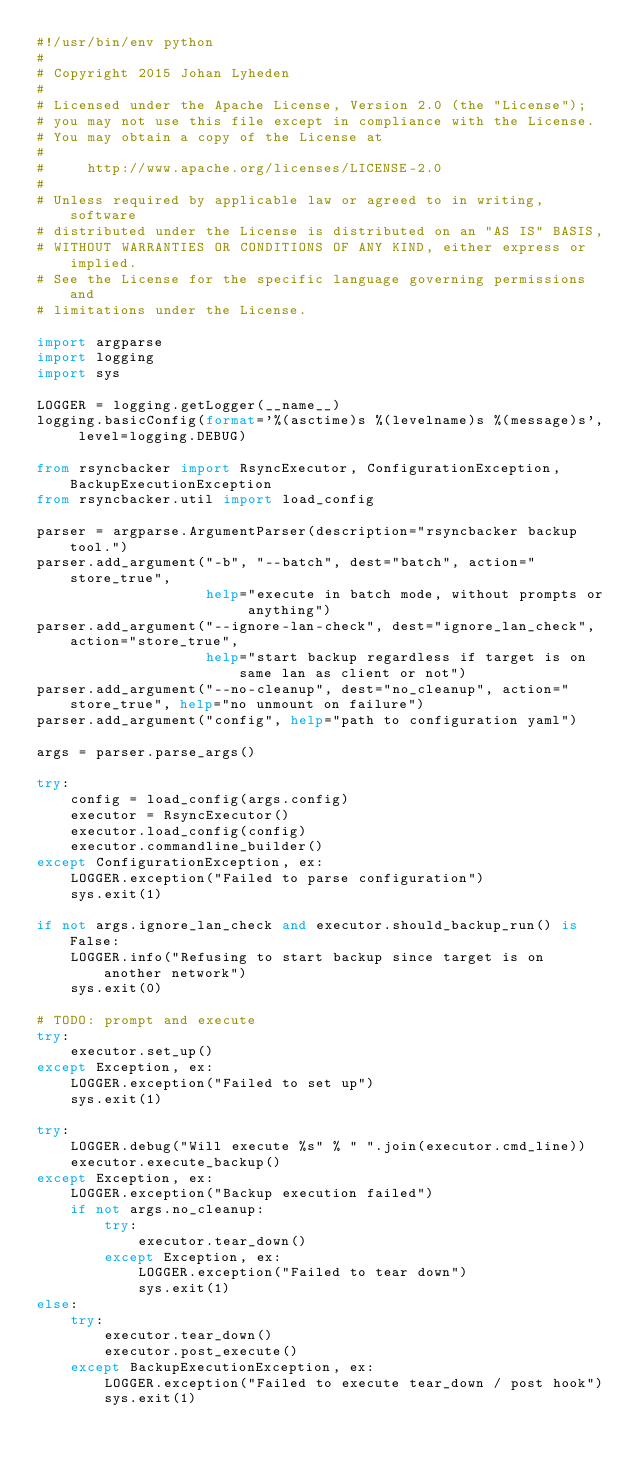<code> <loc_0><loc_0><loc_500><loc_500><_Python_>#!/usr/bin/env python
#
# Copyright 2015 Johan Lyheden
#
# Licensed under the Apache License, Version 2.0 (the "License");
# you may not use this file except in compliance with the License.
# You may obtain a copy of the License at
#
#     http://www.apache.org/licenses/LICENSE-2.0
#
# Unless required by applicable law or agreed to in writing, software
# distributed under the License is distributed on an "AS IS" BASIS,
# WITHOUT WARRANTIES OR CONDITIONS OF ANY KIND, either express or implied.
# See the License for the specific language governing permissions and
# limitations under the License.

import argparse
import logging
import sys

LOGGER = logging.getLogger(__name__)
logging.basicConfig(format='%(asctime)s %(levelname)s %(message)s', level=logging.DEBUG)

from rsyncbacker import RsyncExecutor, ConfigurationException, BackupExecutionException
from rsyncbacker.util import load_config

parser = argparse.ArgumentParser(description="rsyncbacker backup tool.")
parser.add_argument("-b", "--batch", dest="batch", action="store_true",
                    help="execute in batch mode, without prompts or anything")
parser.add_argument("--ignore-lan-check", dest="ignore_lan_check", action="store_true",
                    help="start backup regardless if target is on same lan as client or not")
parser.add_argument("--no-cleanup", dest="no_cleanup", action="store_true", help="no unmount on failure")
parser.add_argument("config", help="path to configuration yaml")

args = parser.parse_args()

try:
    config = load_config(args.config)
    executor = RsyncExecutor()
    executor.load_config(config)
    executor.commandline_builder()
except ConfigurationException, ex:
    LOGGER.exception("Failed to parse configuration")
    sys.exit(1)

if not args.ignore_lan_check and executor.should_backup_run() is False:
    LOGGER.info("Refusing to start backup since target is on another network")
    sys.exit(0)

# TODO: prompt and execute
try:
    executor.set_up()
except Exception, ex:
    LOGGER.exception("Failed to set up")
    sys.exit(1)

try:
    LOGGER.debug("Will execute %s" % " ".join(executor.cmd_line))
    executor.execute_backup()
except Exception, ex:
    LOGGER.exception("Backup execution failed")
    if not args.no_cleanup:
        try:
            executor.tear_down()
        except Exception, ex:
            LOGGER.exception("Failed to tear down")
            sys.exit(1)
else:
    try:
        executor.tear_down()
        executor.post_execute()
    except BackupExecutionException, ex:
        LOGGER.exception("Failed to execute tear_down / post hook")
        sys.exit(1)
</code> 